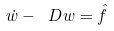Convert formula to latex. <formula><loc_0><loc_0><loc_500><loc_500>\dot { w } - \ D w & = \hat { f }</formula> 